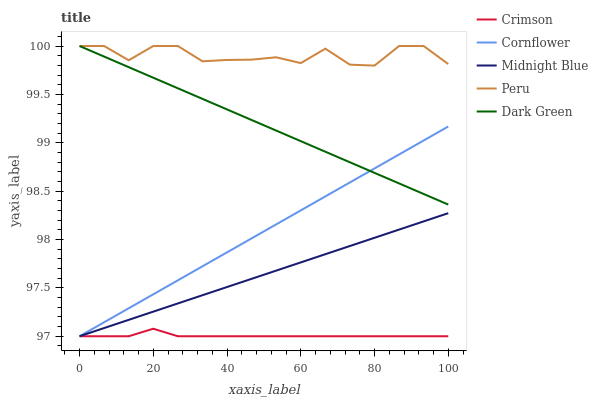Does Crimson have the minimum area under the curve?
Answer yes or no. Yes. Does Peru have the maximum area under the curve?
Answer yes or no. Yes. Does Cornflower have the minimum area under the curve?
Answer yes or no. No. Does Cornflower have the maximum area under the curve?
Answer yes or no. No. Is Cornflower the smoothest?
Answer yes or no. Yes. Is Peru the roughest?
Answer yes or no. Yes. Is Midnight Blue the smoothest?
Answer yes or no. No. Is Midnight Blue the roughest?
Answer yes or no. No. Does Crimson have the lowest value?
Answer yes or no. Yes. Does Peru have the lowest value?
Answer yes or no. No. Does Dark Green have the highest value?
Answer yes or no. Yes. Does Cornflower have the highest value?
Answer yes or no. No. Is Crimson less than Dark Green?
Answer yes or no. Yes. Is Dark Green greater than Crimson?
Answer yes or no. Yes. Does Cornflower intersect Midnight Blue?
Answer yes or no. Yes. Is Cornflower less than Midnight Blue?
Answer yes or no. No. Is Cornflower greater than Midnight Blue?
Answer yes or no. No. Does Crimson intersect Dark Green?
Answer yes or no. No. 